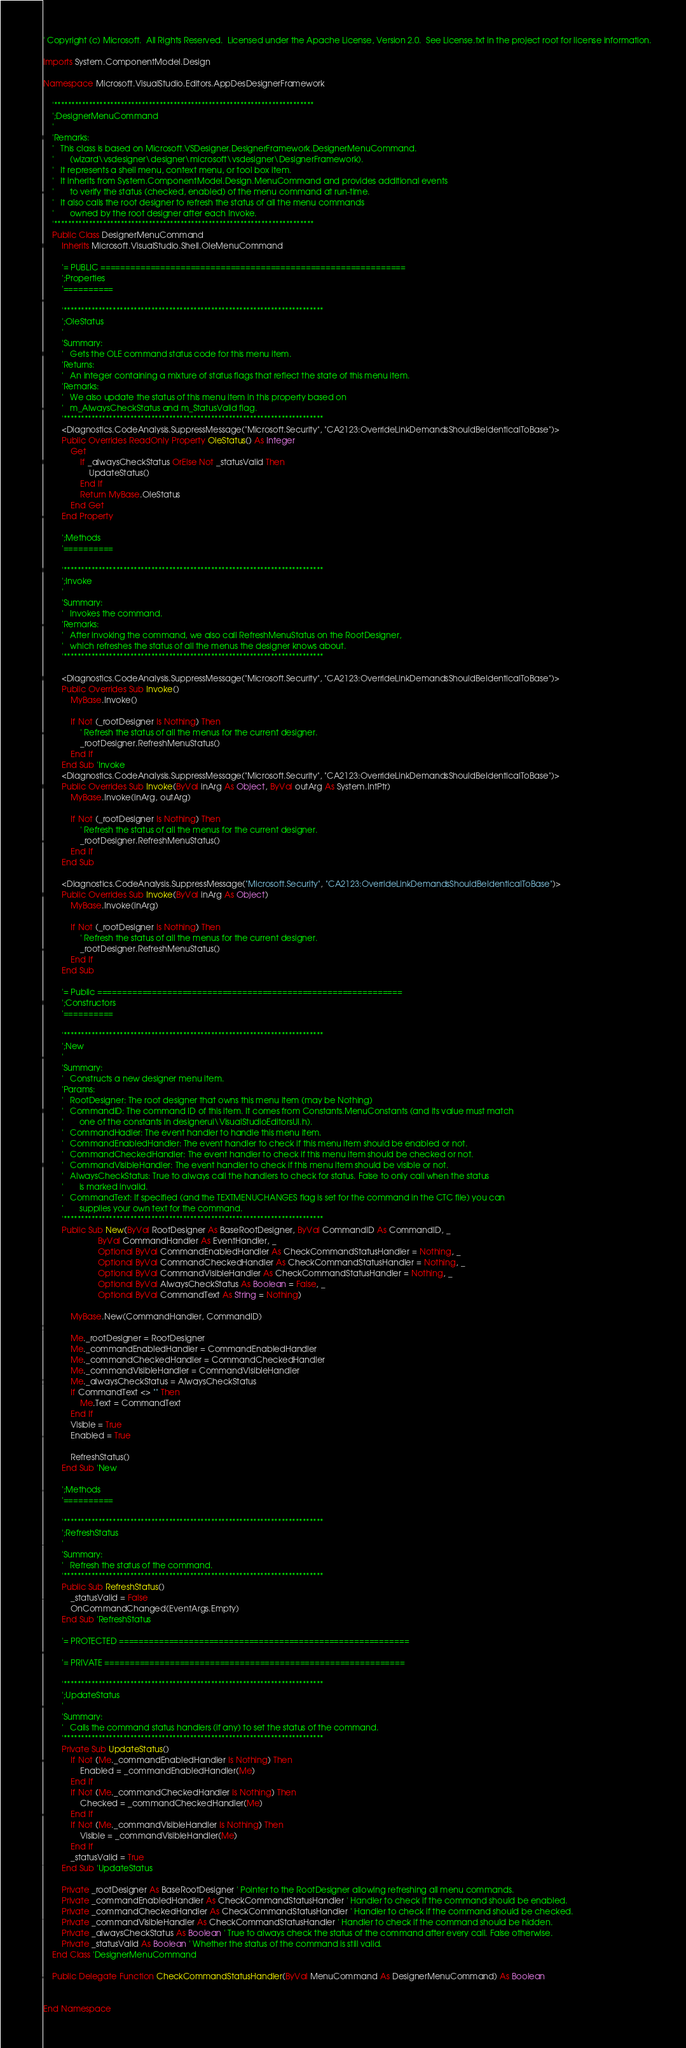Convert code to text. <code><loc_0><loc_0><loc_500><loc_500><_VisualBasic_>' Copyright (c) Microsoft.  All Rights Reserved.  Licensed under the Apache License, Version 2.0.  See License.txt in the project root for license information.

Imports System.ComponentModel.Design

Namespace Microsoft.VisualStudio.Editors.AppDesDesignerFramework

    '**************************************************************************
    ';DesignerMenuCommand
    '
    'Remarks:
    '   This class is based on Microsoft.VSDesigner.DesignerFramework.DesignerMenuCommand.
    '       (wizard\vsdesigner\designer\microsoft\vsdesigner\DesignerFramework).
    '   It represents a shell menu, context menu, or tool box item.
    '   It inherits from System.ComponentModel.Design.MenuCommand and provides additional events
    '       to verify the status (checked, enabled) of the menu command at run-time.
    '   It also calls the root designer to refresh the status of all the menu commands 
    '       owned by the root designer after each Invoke.
    '**************************************************************************
    Public Class DesignerMenuCommand
        Inherits Microsoft.VisualStudio.Shell.OleMenuCommand

        '= PUBLIC =============================================================
        ';Properties
        '==========

        '**************************************************************************
        ';OleStatus
        '
        'Summary:
        '   Gets the OLE command status code for this menu item.
        'Returns:
        '   An integer containing a mixture of status flags that reflect the state of this menu item.
        'Remarks:
        '   We also update the status of this menu item in this property based on 
        '   m_AlwaysCheckStatus and m_StatusValid flag.
        '**************************************************************************
        <Diagnostics.CodeAnalysis.SuppressMessage("Microsoft.Security", "CA2123:OverrideLinkDemandsShouldBeIdenticalToBase")>
        Public Overrides ReadOnly Property OleStatus() As Integer
            Get
                If _alwaysCheckStatus OrElse Not _statusValid Then
                    UpdateStatus()
                End If
                Return MyBase.OleStatus
            End Get
        End Property

        ';Methods
        '==========

        '**************************************************************************
        ';Invoke
        '
        'Summary:
        '   Invokes the command.
        'Remarks:
        '   After invoking the command, we also call RefreshMenuStatus on the RootDesigner,
        '   which refreshes the status of all the menus the designer knows about.
        '**************************************************************************

        <Diagnostics.CodeAnalysis.SuppressMessage("Microsoft.Security", "CA2123:OverrideLinkDemandsShouldBeIdenticalToBase")>
        Public Overrides Sub Invoke()
            MyBase.Invoke()

            If Not (_rootDesigner Is Nothing) Then
                ' Refresh the status of all the menus for the current designer.
                _rootDesigner.RefreshMenuStatus()
            End If
        End Sub 'Invoke
        <Diagnostics.CodeAnalysis.SuppressMessage("Microsoft.Security", "CA2123:OverrideLinkDemandsShouldBeIdenticalToBase")>
        Public Overrides Sub Invoke(ByVal inArg As Object, ByVal outArg As System.IntPtr)
            MyBase.Invoke(inArg, outArg)

            If Not (_rootDesigner Is Nothing) Then
                ' Refresh the status of all the menus for the current designer.
                _rootDesigner.RefreshMenuStatus()
            End If
        End Sub

        <Diagnostics.CodeAnalysis.SuppressMessage("Microsoft.Security", "CA2123:OverrideLinkDemandsShouldBeIdenticalToBase")>
        Public Overrides Sub Invoke(ByVal inArg As Object)
            MyBase.Invoke(inArg)

            If Not (_rootDesigner Is Nothing) Then
                ' Refresh the status of all the menus for the current designer.
                _rootDesigner.RefreshMenuStatus()
            End If
        End Sub

        '= Public =============================================================
        ';Constructors
        '==========

        '**************************************************************************
        ';New
        '
        'Summary:
        '   Constructs a new designer menu item.
        'Params:
        '   RootDesigner: The root designer that owns this menu item (may be Nothing)
        '   CommandID: The command ID of this item. It comes from Constants.MenuConstants (and its value must match
        '       one of the constants in designerui\VisualStudioEditorsUI.h).
        '   CommandHadler: The event handler to handle this menu item.
        '   CommandEnabledHandler: The event handler to check if this menu item should be enabled or not.
        '   CommandCheckedHandler: The event handler to check if this menu item should be checked or not.
        '   CommandVisibleHandler: The event handler to check if this menu item should be visible or not.
        '   AlwaysCheckStatus: True to always call the handlers to check for status. False to only call when the status
        '       is marked invalid.
        '   CommandText: If specified (and the TEXTMENUCHANGES flag is set for the command in the CTC file) you can 
        '       supplies your own text for the command. 
        '**************************************************************************
        Public Sub New(ByVal RootDesigner As BaseRootDesigner, ByVal CommandID As CommandID, _
                        ByVal CommandHandler As EventHandler, _
                        Optional ByVal CommandEnabledHandler As CheckCommandStatusHandler = Nothing, _
                        Optional ByVal CommandCheckedHandler As CheckCommandStatusHandler = Nothing, _
                        Optional ByVal CommandVisibleHandler As CheckCommandStatusHandler = Nothing, _
                        Optional ByVal AlwaysCheckStatus As Boolean = False, _
                        Optional ByVal CommandText As String = Nothing)

            MyBase.New(CommandHandler, CommandID)

            Me._rootDesigner = RootDesigner
            Me._commandEnabledHandler = CommandEnabledHandler
            Me._commandCheckedHandler = CommandCheckedHandler
            Me._commandVisibleHandler = CommandVisibleHandler
            Me._alwaysCheckStatus = AlwaysCheckStatus
            If CommandText <> "" Then
                Me.Text = CommandText
            End If
            Visible = True
            Enabled = True

            RefreshStatus()
        End Sub 'New

        ';Methods
        '==========

        '**************************************************************************
        ';RefreshStatus
        '
        'Summary:
        '   Refresh the status of the command.
        '**************************************************************************
        Public Sub RefreshStatus()
            _statusValid = False
            OnCommandChanged(EventArgs.Empty)
        End Sub 'RefreshStatus

        '= PROTECTED ==========================================================

        '= PRIVATE ============================================================

        '**************************************************************************
        ';UpdateStatus
        '
        'Summary:
        '   Calls the command status handlers (if any) to set the status of the command.
        '**************************************************************************
        Private Sub UpdateStatus()
            If Not (Me._commandEnabledHandler Is Nothing) Then
                Enabled = _commandEnabledHandler(Me)
            End If
            If Not (Me._commandCheckedHandler Is Nothing) Then
                Checked = _commandCheckedHandler(Me)
            End If
            If Not (Me._commandVisibleHandler Is Nothing) Then
                Visible = _commandVisibleHandler(Me)
            End If
            _statusValid = True
        End Sub 'UpdateStatus

        Private _rootDesigner As BaseRootDesigner ' Pointer to the RootDesigner allowing refreshing all menu commands.
        Private _commandEnabledHandler As CheckCommandStatusHandler ' Handler to check if the command should be enabled.
        Private _commandCheckedHandler As CheckCommandStatusHandler ' Handler to check if the command should be checked.
        Private _commandVisibleHandler As CheckCommandStatusHandler ' Handler to check if the command should be hidden.
        Private _alwaysCheckStatus As Boolean ' True to always check the status of the command after every call. False otherwise.
        Private _statusValid As Boolean ' Whether the status of the command is still valid.
    End Class 'DesignerMenuCommand

    Public Delegate Function CheckCommandStatusHandler(ByVal MenuCommand As DesignerMenuCommand) As Boolean


End Namespace
</code> 